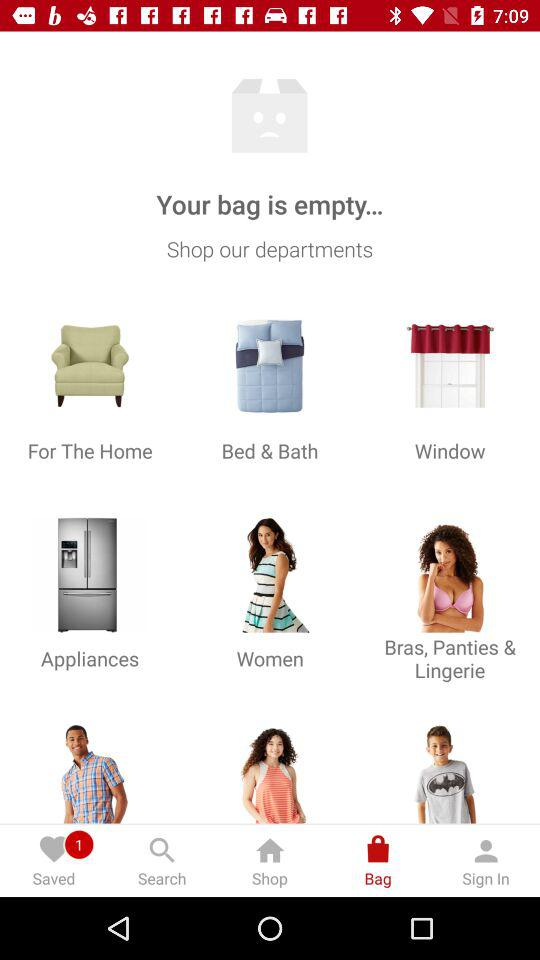How many items are in the bag?
Answer the question using a single word or phrase. 0 